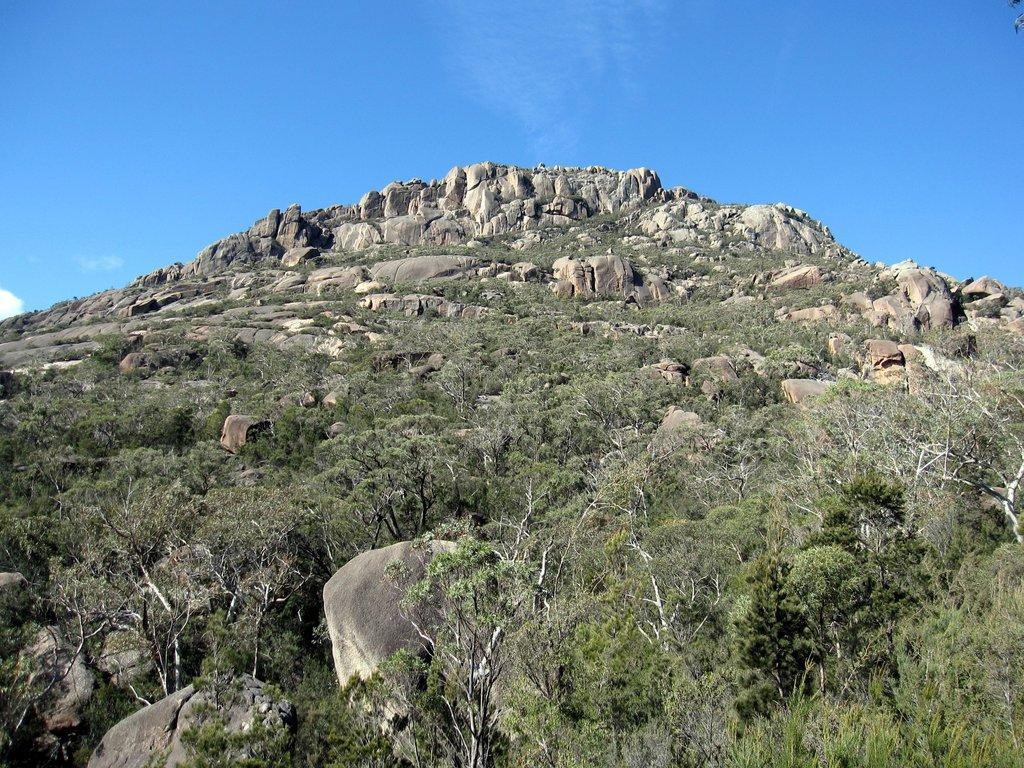What type of vegetation is visible in the front of the image? There are trees in the front of the image. What type of geographical feature can be seen in the background of the image? There are mountains in the background of the image. What is the condition of the sky in the image? The sky is cloudy in the image. Can you tell me where the kettle is located in the image? There is no kettle present in the image. What do you believe about the mountains in the image? The question is asking for an opinion, which is not relevant to the facts provided. The mountains are simply visible in the background of the image. 